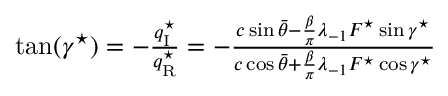<formula> <loc_0><loc_0><loc_500><loc_500>\begin{array} { r } { \tan ( \gamma ^ { ^ { * } } ) = - \frac { q _ { I } ^ { ^ { * } } } { q _ { R } ^ { ^ { * } } } = - \frac { c \sin \bar { \theta } - { \frac { \beta } { \pi } } \lambda _ { - 1 } F ^ { ^ { * } } \sin \gamma ^ { ^ { * } } } { c \cos \bar { \theta } + { \frac { \beta } { \pi } } \lambda _ { - 1 } F ^ { ^ { * } } \cos \gamma ^ { ^ { * } } } } \end{array}</formula> 